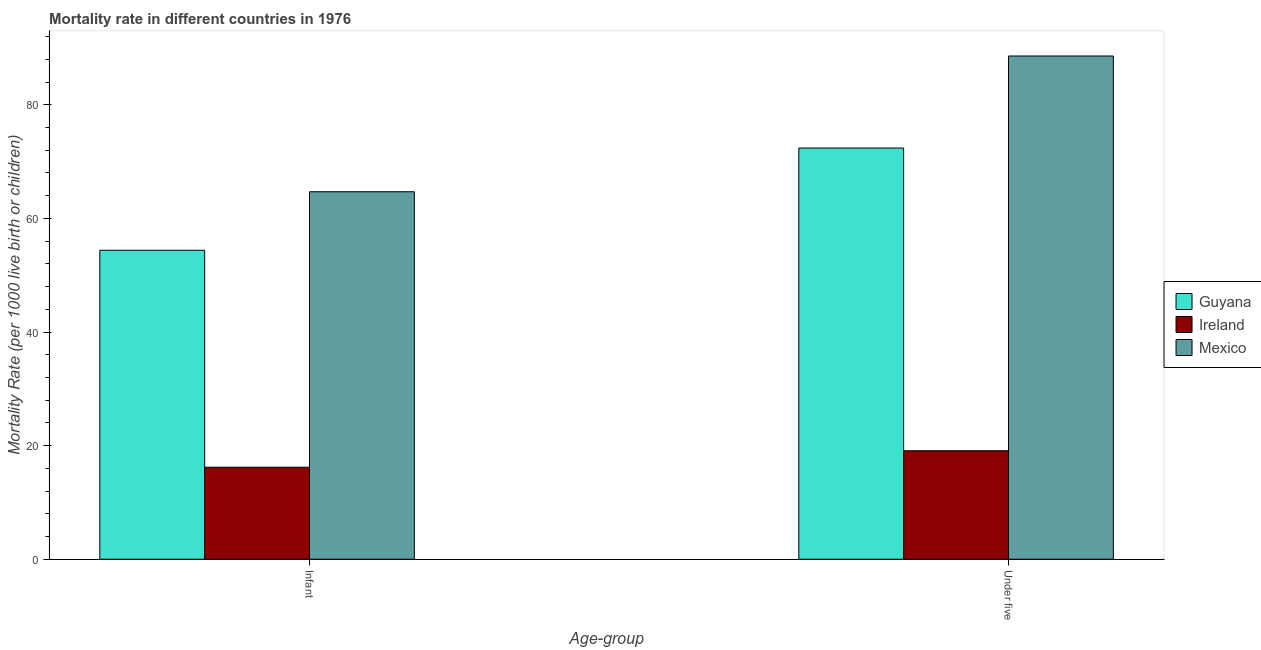Are the number of bars on each tick of the X-axis equal?
Your answer should be compact. Yes. How many bars are there on the 2nd tick from the left?
Your answer should be compact. 3. How many bars are there on the 2nd tick from the right?
Offer a very short reply. 3. What is the label of the 1st group of bars from the left?
Your answer should be very brief. Infant. Across all countries, what is the maximum under-5 mortality rate?
Ensure brevity in your answer.  88.6. In which country was the under-5 mortality rate maximum?
Give a very brief answer. Mexico. In which country was the under-5 mortality rate minimum?
Provide a succinct answer. Ireland. What is the total infant mortality rate in the graph?
Offer a terse response. 135.3. What is the difference between the under-5 mortality rate in Mexico and that in Ireland?
Ensure brevity in your answer.  69.5. What is the difference between the under-5 mortality rate in Guyana and the infant mortality rate in Mexico?
Ensure brevity in your answer.  7.7. What is the average under-5 mortality rate per country?
Provide a succinct answer. 60.03. What is the difference between the infant mortality rate and under-5 mortality rate in Mexico?
Provide a short and direct response. -23.9. In how many countries, is the infant mortality rate greater than 16 ?
Provide a succinct answer. 3. What is the ratio of the infant mortality rate in Ireland to that in Guyana?
Give a very brief answer. 0.3. Is the under-5 mortality rate in Guyana less than that in Mexico?
Provide a succinct answer. Yes. What does the 3rd bar from the left in Infant represents?
Offer a very short reply. Mexico. What does the 3rd bar from the right in Under five represents?
Offer a very short reply. Guyana. How many bars are there?
Provide a short and direct response. 6. Are all the bars in the graph horizontal?
Your answer should be compact. No. How many countries are there in the graph?
Your response must be concise. 3. What is the difference between two consecutive major ticks on the Y-axis?
Keep it short and to the point. 20. Are the values on the major ticks of Y-axis written in scientific E-notation?
Provide a short and direct response. No. How many legend labels are there?
Keep it short and to the point. 3. How are the legend labels stacked?
Offer a very short reply. Vertical. What is the title of the graph?
Provide a succinct answer. Mortality rate in different countries in 1976. Does "Hong Kong" appear as one of the legend labels in the graph?
Provide a succinct answer. No. What is the label or title of the X-axis?
Offer a terse response. Age-group. What is the label or title of the Y-axis?
Your response must be concise. Mortality Rate (per 1000 live birth or children). What is the Mortality Rate (per 1000 live birth or children) in Guyana in Infant?
Offer a very short reply. 54.4. What is the Mortality Rate (per 1000 live birth or children) in Ireland in Infant?
Your response must be concise. 16.2. What is the Mortality Rate (per 1000 live birth or children) in Mexico in Infant?
Offer a terse response. 64.7. What is the Mortality Rate (per 1000 live birth or children) of Guyana in Under five?
Keep it short and to the point. 72.4. What is the Mortality Rate (per 1000 live birth or children) of Ireland in Under five?
Give a very brief answer. 19.1. What is the Mortality Rate (per 1000 live birth or children) of Mexico in Under five?
Your response must be concise. 88.6. Across all Age-group, what is the maximum Mortality Rate (per 1000 live birth or children) of Guyana?
Your answer should be compact. 72.4. Across all Age-group, what is the maximum Mortality Rate (per 1000 live birth or children) in Mexico?
Provide a short and direct response. 88.6. Across all Age-group, what is the minimum Mortality Rate (per 1000 live birth or children) of Guyana?
Your answer should be compact. 54.4. Across all Age-group, what is the minimum Mortality Rate (per 1000 live birth or children) in Ireland?
Give a very brief answer. 16.2. Across all Age-group, what is the minimum Mortality Rate (per 1000 live birth or children) in Mexico?
Keep it short and to the point. 64.7. What is the total Mortality Rate (per 1000 live birth or children) in Guyana in the graph?
Give a very brief answer. 126.8. What is the total Mortality Rate (per 1000 live birth or children) of Ireland in the graph?
Provide a short and direct response. 35.3. What is the total Mortality Rate (per 1000 live birth or children) in Mexico in the graph?
Ensure brevity in your answer.  153.3. What is the difference between the Mortality Rate (per 1000 live birth or children) in Guyana in Infant and that in Under five?
Your response must be concise. -18. What is the difference between the Mortality Rate (per 1000 live birth or children) of Mexico in Infant and that in Under five?
Your response must be concise. -23.9. What is the difference between the Mortality Rate (per 1000 live birth or children) in Guyana in Infant and the Mortality Rate (per 1000 live birth or children) in Ireland in Under five?
Give a very brief answer. 35.3. What is the difference between the Mortality Rate (per 1000 live birth or children) of Guyana in Infant and the Mortality Rate (per 1000 live birth or children) of Mexico in Under five?
Ensure brevity in your answer.  -34.2. What is the difference between the Mortality Rate (per 1000 live birth or children) in Ireland in Infant and the Mortality Rate (per 1000 live birth or children) in Mexico in Under five?
Offer a very short reply. -72.4. What is the average Mortality Rate (per 1000 live birth or children) of Guyana per Age-group?
Your answer should be compact. 63.4. What is the average Mortality Rate (per 1000 live birth or children) in Ireland per Age-group?
Provide a short and direct response. 17.65. What is the average Mortality Rate (per 1000 live birth or children) in Mexico per Age-group?
Offer a terse response. 76.65. What is the difference between the Mortality Rate (per 1000 live birth or children) of Guyana and Mortality Rate (per 1000 live birth or children) of Ireland in Infant?
Ensure brevity in your answer.  38.2. What is the difference between the Mortality Rate (per 1000 live birth or children) in Ireland and Mortality Rate (per 1000 live birth or children) in Mexico in Infant?
Provide a short and direct response. -48.5. What is the difference between the Mortality Rate (per 1000 live birth or children) in Guyana and Mortality Rate (per 1000 live birth or children) in Ireland in Under five?
Make the answer very short. 53.3. What is the difference between the Mortality Rate (per 1000 live birth or children) in Guyana and Mortality Rate (per 1000 live birth or children) in Mexico in Under five?
Keep it short and to the point. -16.2. What is the difference between the Mortality Rate (per 1000 live birth or children) of Ireland and Mortality Rate (per 1000 live birth or children) of Mexico in Under five?
Offer a very short reply. -69.5. What is the ratio of the Mortality Rate (per 1000 live birth or children) in Guyana in Infant to that in Under five?
Make the answer very short. 0.75. What is the ratio of the Mortality Rate (per 1000 live birth or children) of Ireland in Infant to that in Under five?
Make the answer very short. 0.85. What is the ratio of the Mortality Rate (per 1000 live birth or children) of Mexico in Infant to that in Under five?
Keep it short and to the point. 0.73. What is the difference between the highest and the second highest Mortality Rate (per 1000 live birth or children) in Guyana?
Your response must be concise. 18. What is the difference between the highest and the second highest Mortality Rate (per 1000 live birth or children) of Ireland?
Your answer should be compact. 2.9. What is the difference between the highest and the second highest Mortality Rate (per 1000 live birth or children) of Mexico?
Provide a succinct answer. 23.9. What is the difference between the highest and the lowest Mortality Rate (per 1000 live birth or children) of Guyana?
Make the answer very short. 18. What is the difference between the highest and the lowest Mortality Rate (per 1000 live birth or children) in Mexico?
Make the answer very short. 23.9. 